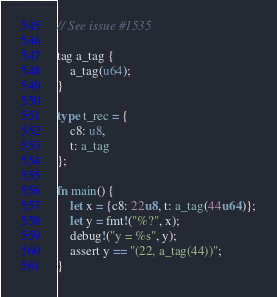<code> <loc_0><loc_0><loc_500><loc_500><_Rust_>// See issue #1535

tag a_tag {
    a_tag(u64);
}

type t_rec = {
    c8: u8,
    t: a_tag
};

fn main() {
    let x = {c8: 22u8, t: a_tag(44u64)};
    let y = fmt!("%?", x);
    debug!("y = %s", y);
    assert y == "(22, a_tag(44))";
}
</code> 